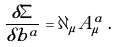Convert formula to latex. <formula><loc_0><loc_0><loc_500><loc_500>\frac { \delta \Sigma } { \delta b ^ { a } } = \partial _ { \mu } A ^ { a } _ { \mu } \, .</formula> 